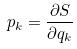Convert formula to latex. <formula><loc_0><loc_0><loc_500><loc_500>p _ { k } = \frac { \partial S } { \partial q _ { k } }</formula> 